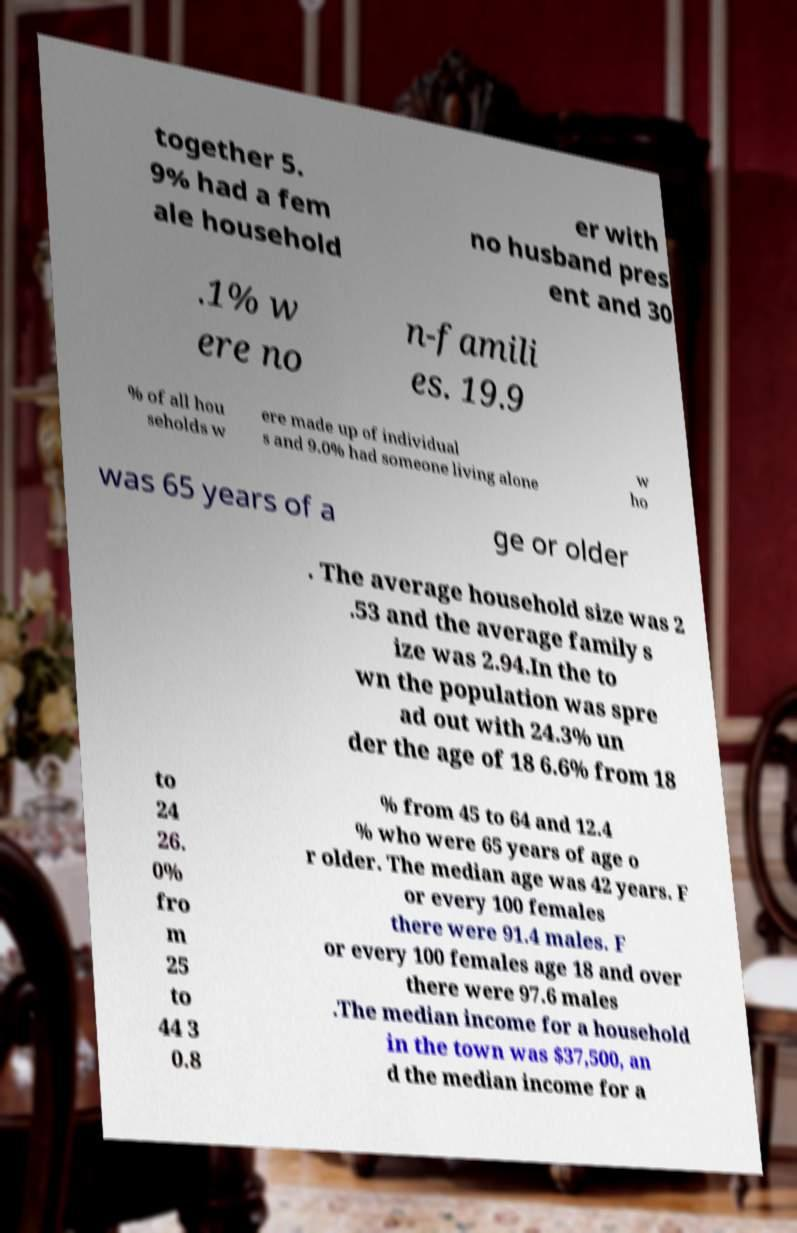What messages or text are displayed in this image? I need them in a readable, typed format. together 5. 9% had a fem ale household er with no husband pres ent and 30 .1% w ere no n-famili es. 19.9 % of all hou seholds w ere made up of individual s and 9.0% had someone living alone w ho was 65 years of a ge or older . The average household size was 2 .53 and the average family s ize was 2.94.In the to wn the population was spre ad out with 24.3% un der the age of 18 6.6% from 18 to 24 26. 0% fro m 25 to 44 3 0.8 % from 45 to 64 and 12.4 % who were 65 years of age o r older. The median age was 42 years. F or every 100 females there were 91.4 males. F or every 100 females age 18 and over there were 97.6 males .The median income for a household in the town was $37,500, an d the median income for a 